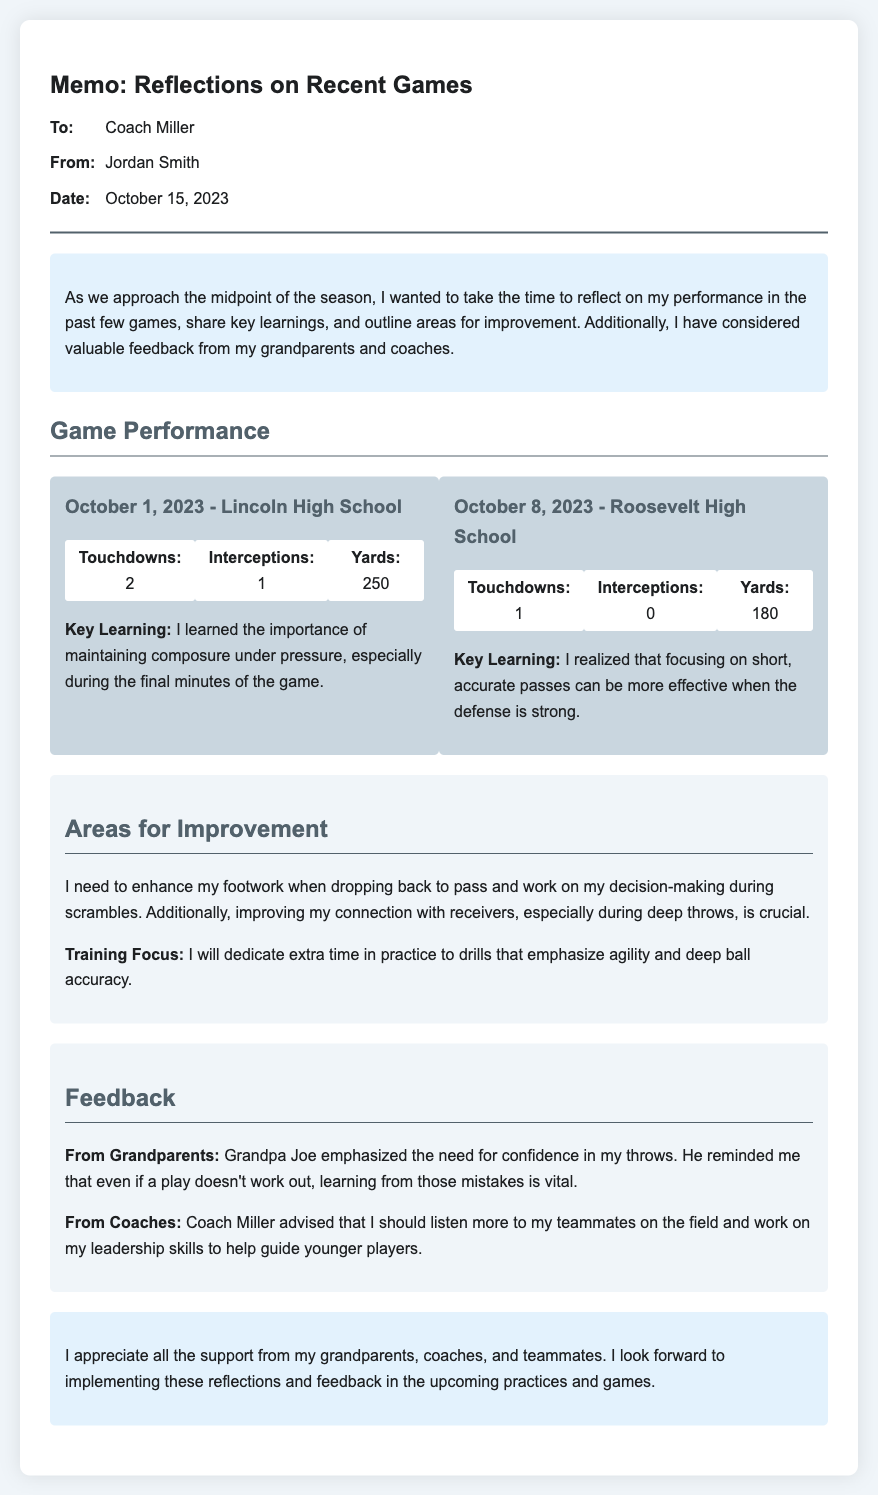what is the date of the memo? The date of the memo is explicitly stated in the header of the document.
Answer: October 15, 2023 who is the memo addressed to? The memo specifies the recipient in the header section.
Answer: Coach Miller how many touchdowns were scored against Lincoln High School? The number of touchdowns is listed in the performance stats for that game.
Answer: 2 what area for improvement is mentioned in the memo? The memo outlines specific areas for improvement under that section.
Answer: Enhance footwork when dropping back to pass what did Grandpa Joe emphasize in his feedback? The feedback section mentions specific advice from Grandpa Joe.
Answer: Confidence in my throws what key learning was identified from the game against Roosevelt High School? The key learning is mentioned in the game performance section for that specific game.
Answer: Focusing on short, accurate passes what is the training focus outlined in the memo? The memo details the training focus that will be implemented to improve performance.
Answer: Drills that emphasize agility and deep ball accuracy how many interceptions were made against Roosevelt High School? The number of interceptions is specified in the performance stats for that game.
Answer: 0 